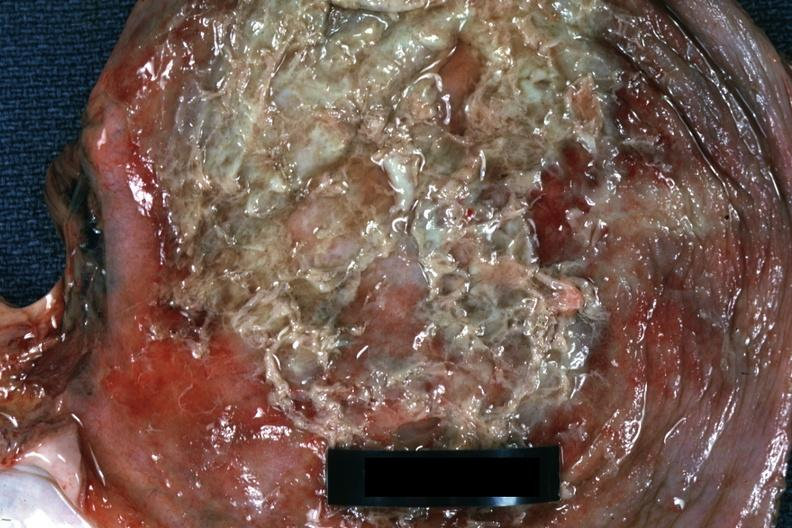does this image show close-up view of purulent exudate over diaphragm very good?
Answer the question using a single word or phrase. Yes 